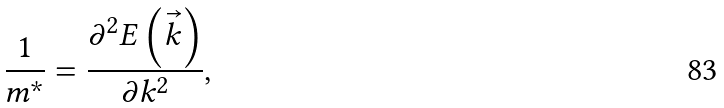Convert formula to latex. <formula><loc_0><loc_0><loc_500><loc_500>\frac { 1 } { m ^ { * } } = \frac { \partial ^ { 2 } E \left ( \vec { k } \right ) } { \partial k ^ { 2 } } ,</formula> 